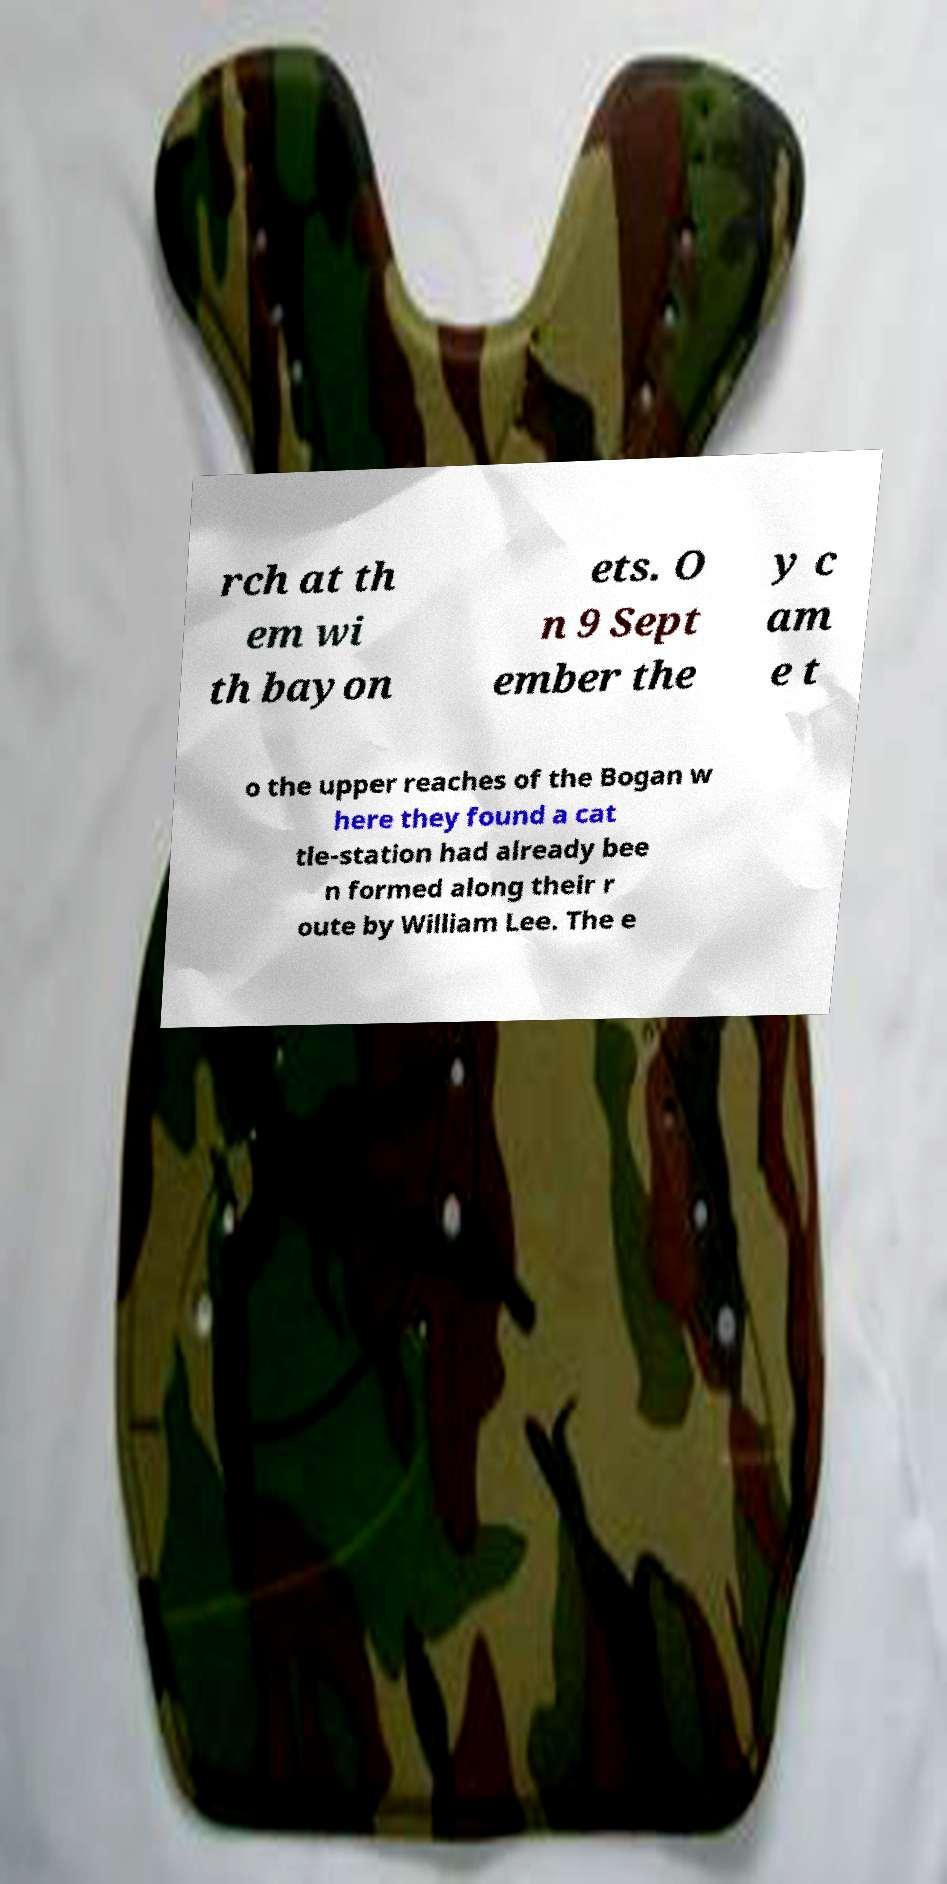For documentation purposes, I need the text within this image transcribed. Could you provide that? rch at th em wi th bayon ets. O n 9 Sept ember the y c am e t o the upper reaches of the Bogan w here they found a cat tle-station had already bee n formed along their r oute by William Lee. The e 